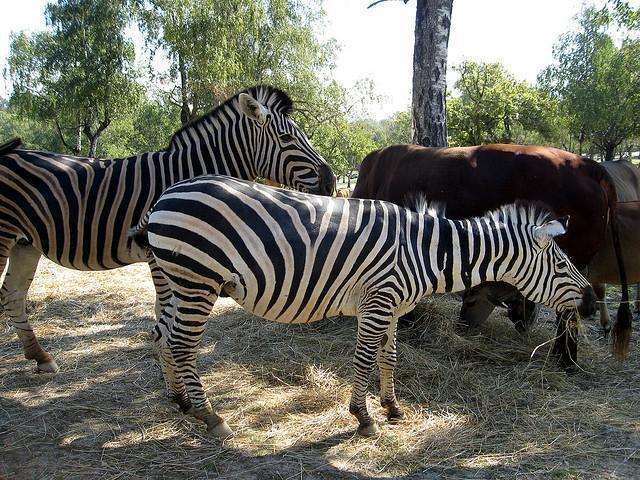Where are the animals?
From the following four choices, select the correct answer to address the question.
Options: Cages, indoors, trailer, outdoors. Outdoors. 